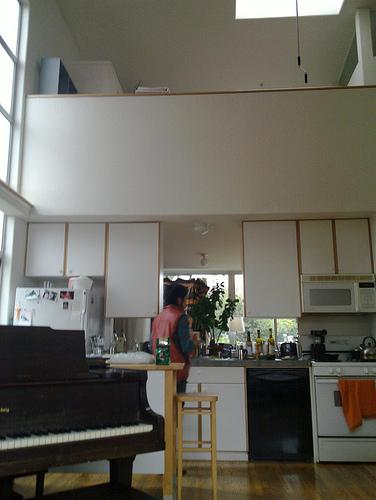Which furniture item is mentioned in the image captions and where is it located? A wooden bar stool is mentioned as being in the kitchen. What items idicate that this image might be set inside a room of a house? A door, window, piano, fridge near the wall, and a table on the floor indicate that the image might be set inside a room of a house. Suppose you are creating a visual quiz. Make a multiple-choice question related to the image. Correct Answer: C. Orange Identify an object of interest in the kitchen part of the image. An orange towel on a stove catches attention in the kitchen part of the image. In an advertising context, describe a product being used in the kitchen. Introducing our black automatic dishwasher, efficient and elegant, perfectly blending into modern kitchens while making dishwashing a breeze. Find three captioned objects associated with the person in the image. Face of the person, a man wearing a jacket, and person standing wearing a red vest are associated with the person in the image. Explain a scene that can be constructed based on the image descriptions. A person is standing in the kitchen, surrounded by various appliances and objects, such as a piano, a wooden bar stool, a refrigerator, a microwave oven above a stove, and an orange towel on the stove. Mention two kitchen appliances featured in this image. A black dishwasher and a microwave oven above a stove are featured in the image. What type of musical instrument is present in the image? A black piano with white keys is present in the image. Describe two elements related to the fridge in the image. The top door of a white fridge and a handle on the refrigerator are two elements related to the fridge in the image. 